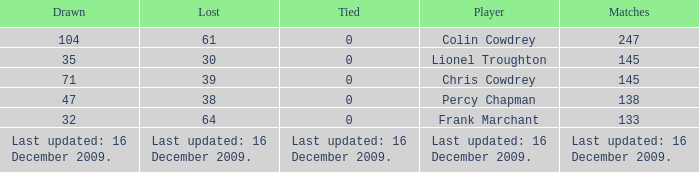I want to know the tie for drawn of 47 0.0. 